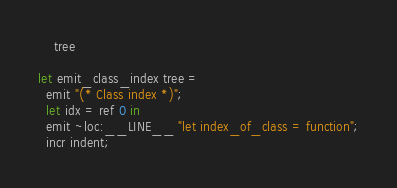Convert code to text. <code><loc_0><loc_0><loc_500><loc_500><_OCaml_>    tree

let emit_class_index tree =
  emit "(* Class index *)";
  let idx = ref 0 in
  emit ~loc:__LINE__ "let index_of_class = function";
  incr indent;</code> 